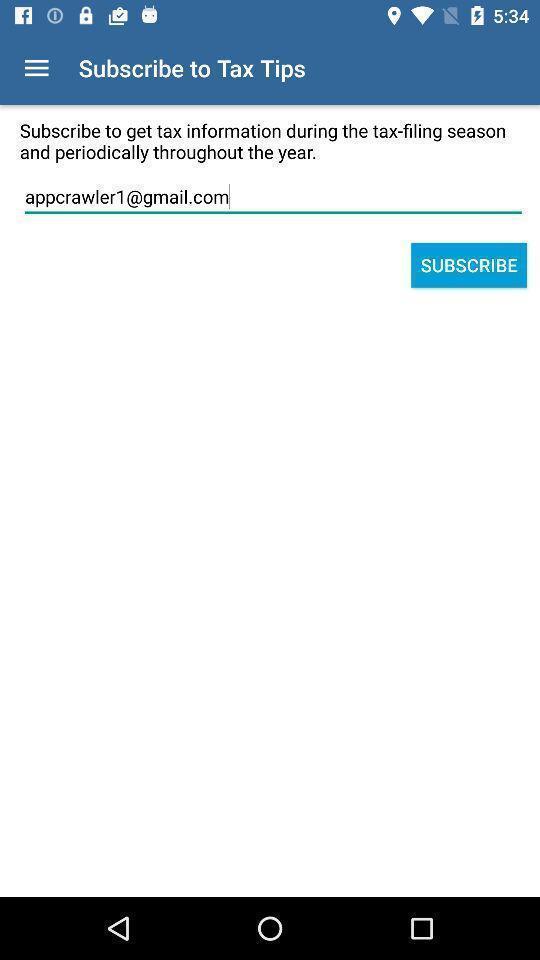Explain what's happening in this screen capture. Screen displaying user information in subscription page. 